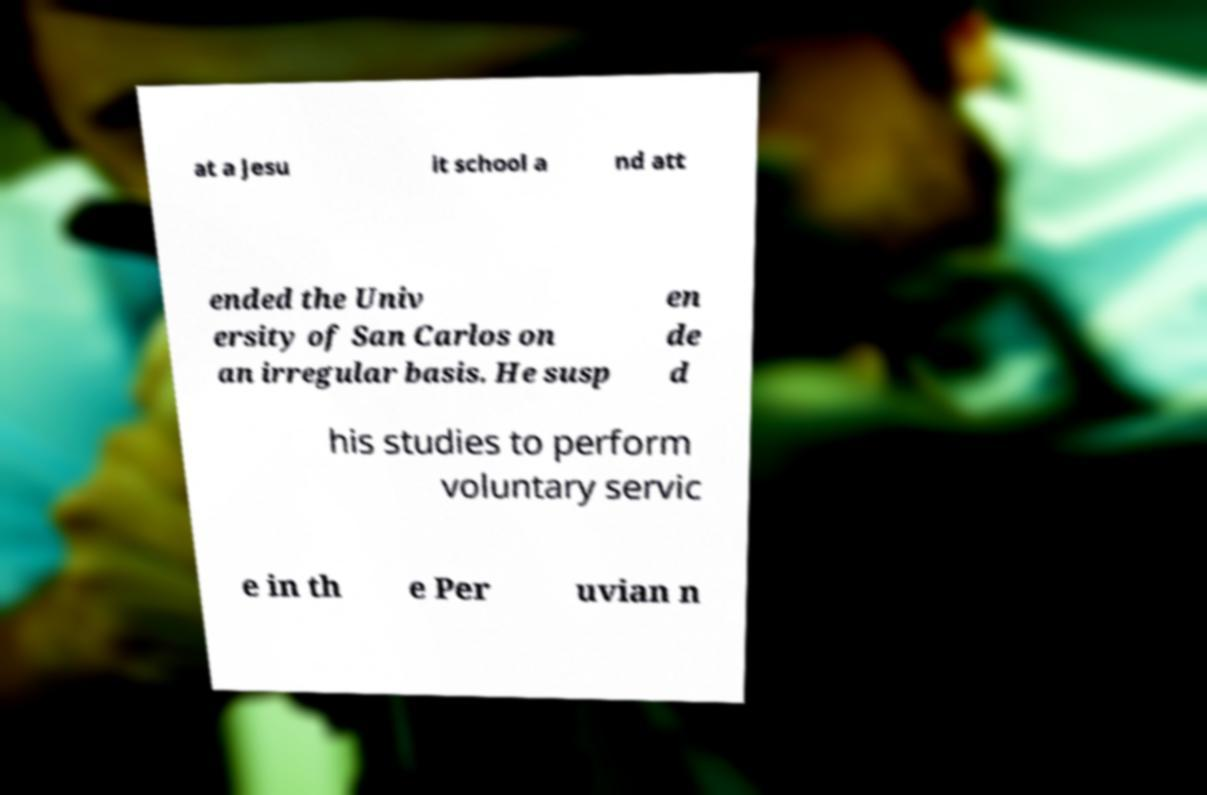Can you read and provide the text displayed in the image?This photo seems to have some interesting text. Can you extract and type it out for me? at a Jesu it school a nd att ended the Univ ersity of San Carlos on an irregular basis. He susp en de d his studies to perform voluntary servic e in th e Per uvian n 